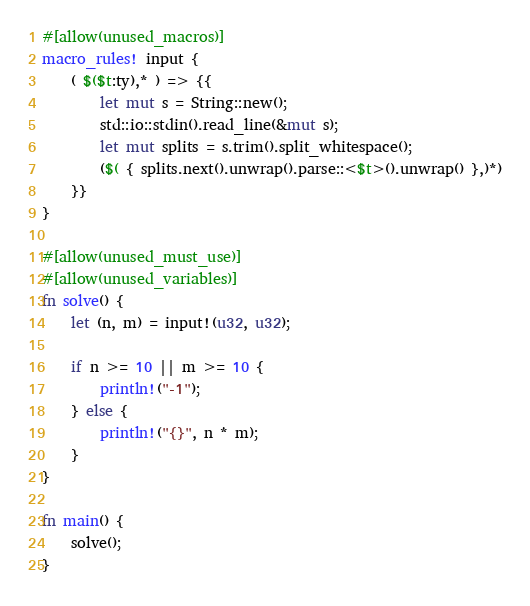Convert code to text. <code><loc_0><loc_0><loc_500><loc_500><_Rust_>#[allow(unused_macros)]
macro_rules! input {
    ( $($t:ty),* ) => {{
        let mut s = String::new();
        std::io::stdin().read_line(&mut s);
        let mut splits = s.trim().split_whitespace();
        ($( { splits.next().unwrap().parse::<$t>().unwrap() },)*)
    }}
}

#[allow(unused_must_use)]
#[allow(unused_variables)]
fn solve() {
    let (n, m) = input!(u32, u32);

    if n >= 10 || m >= 10 {
        println!("-1");
    } else {
        println!("{}", n * m);
    }
}

fn main() {
    solve();
}
</code> 